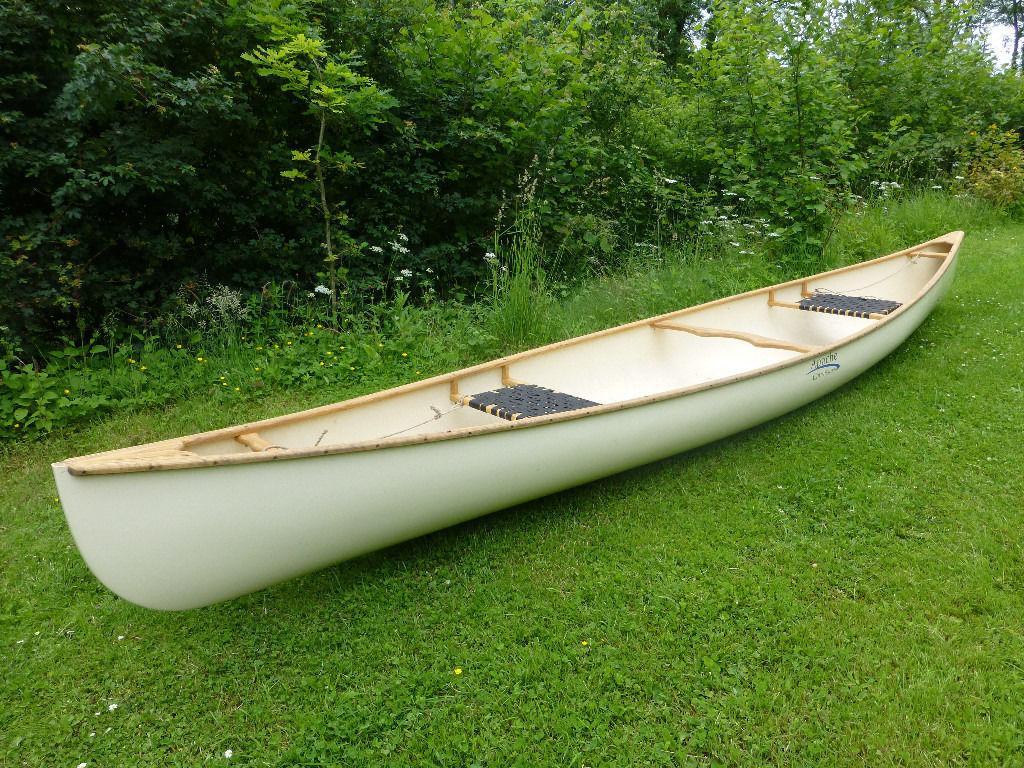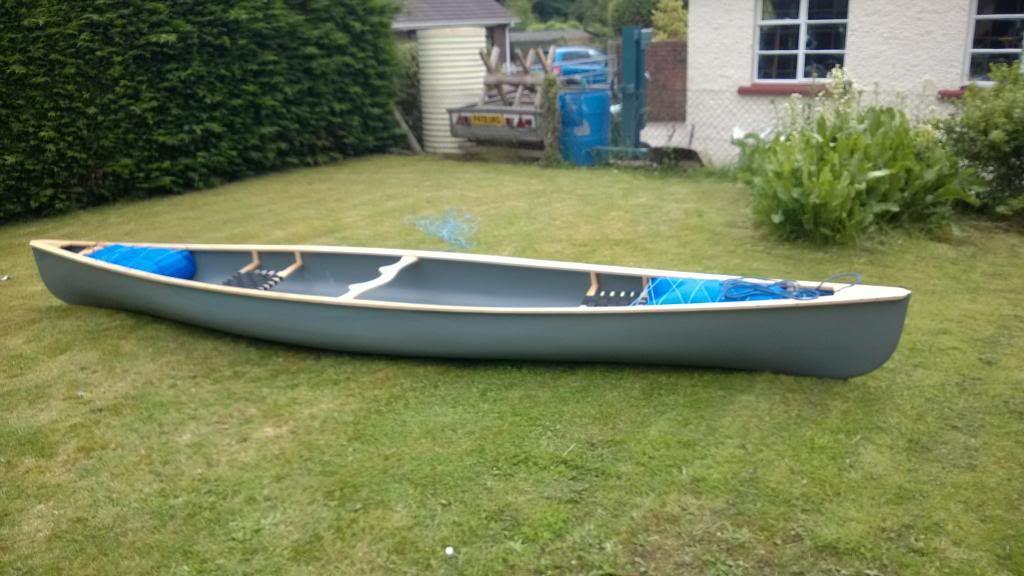The first image is the image on the left, the second image is the image on the right. Given the left and right images, does the statement "Two canoes are sitting in the grass next to a building." hold true? Answer yes or no. No. The first image is the image on the left, the second image is the image on the right. For the images shown, is this caption "Each image features an empty canoe sitting on green grass, and one image features a white canoe next to a strip of dark pavement, with a crumpled blue tarp behind it." true? Answer yes or no. No. 